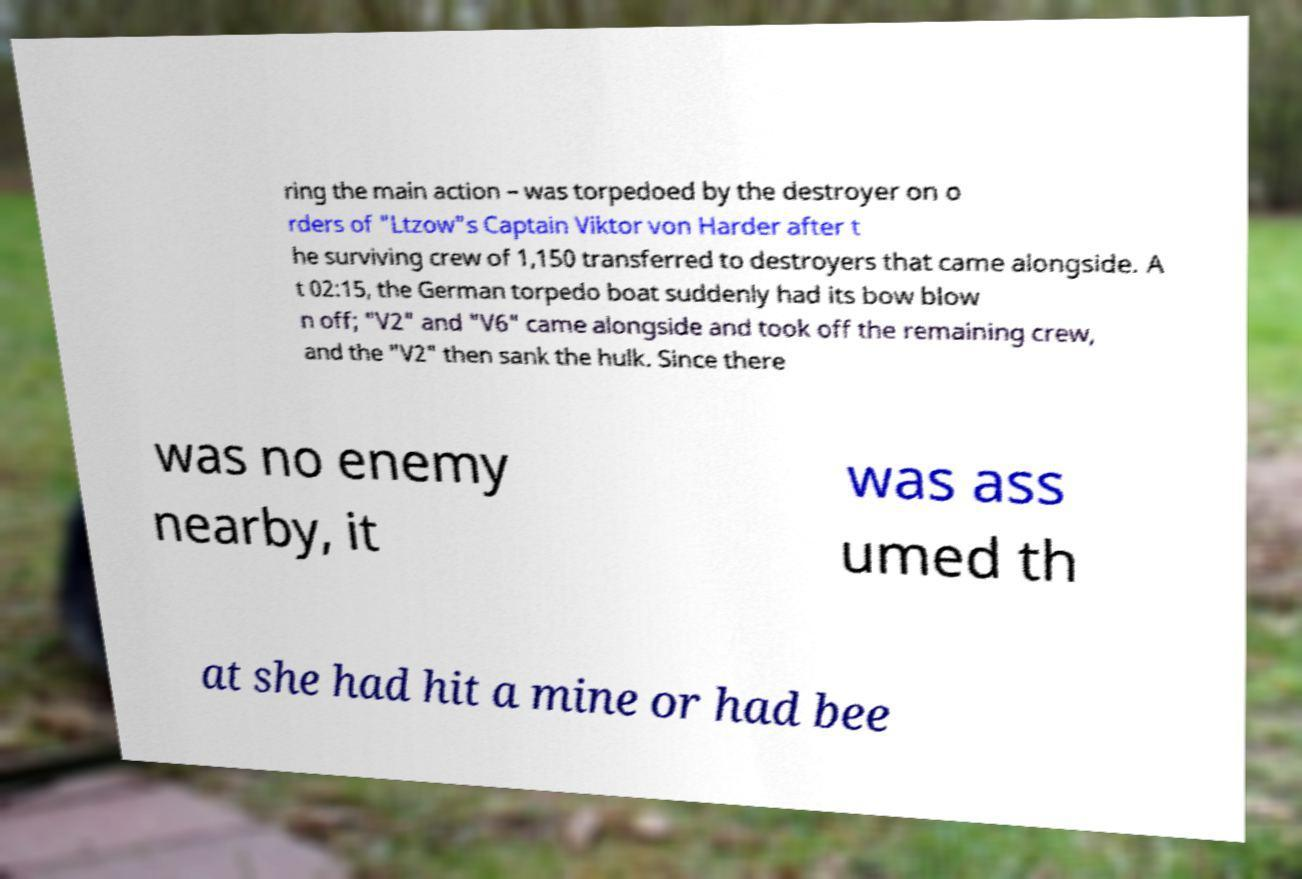There's text embedded in this image that I need extracted. Can you transcribe it verbatim? ring the main action – was torpedoed by the destroyer on o rders of "Ltzow"s Captain Viktor von Harder after t he surviving crew of 1,150 transferred to destroyers that came alongside. A t 02:15, the German torpedo boat suddenly had its bow blow n off; "V2" and "V6" came alongside and took off the remaining crew, and the "V2" then sank the hulk. Since there was no enemy nearby, it was ass umed th at she had hit a mine or had bee 